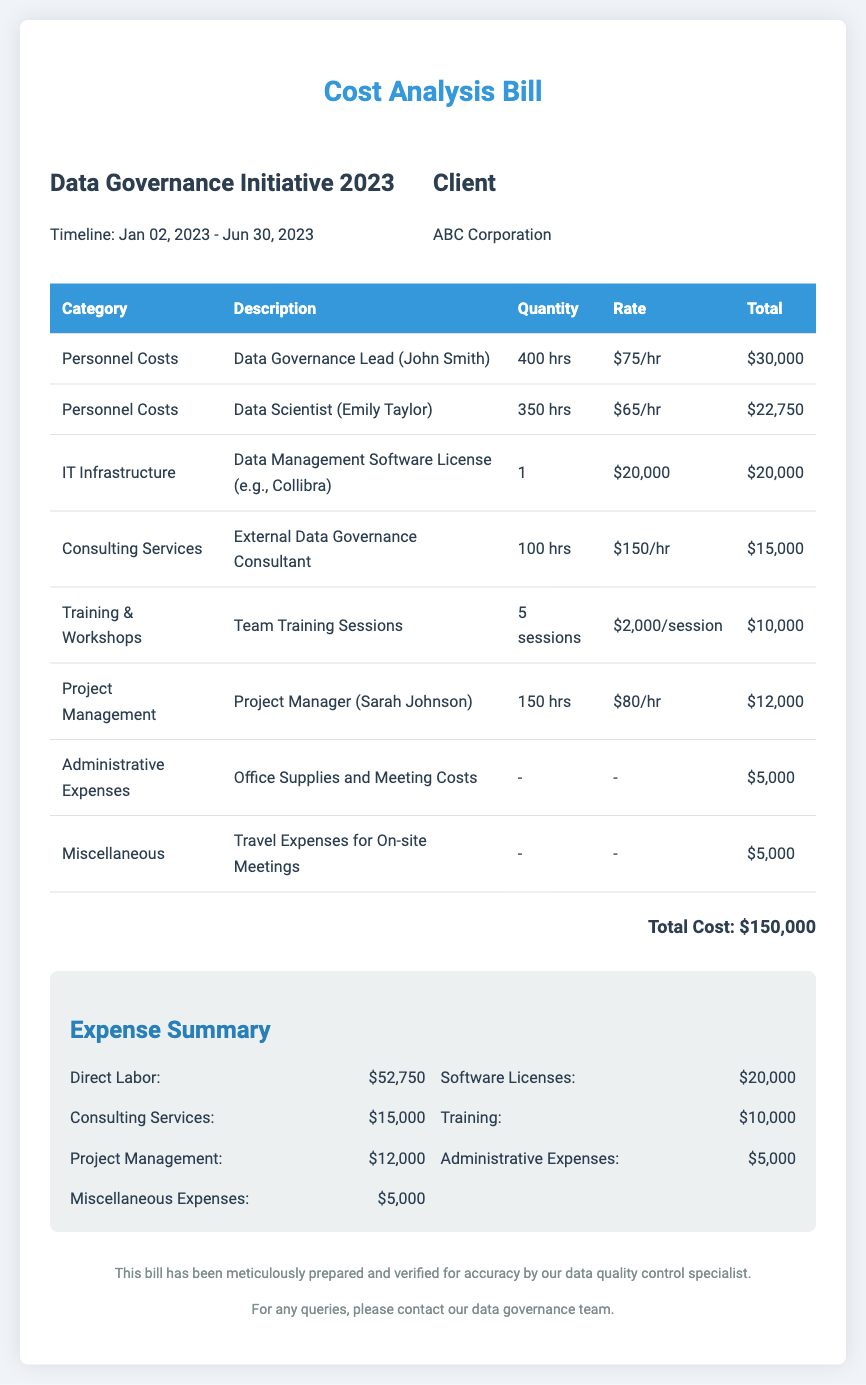What is the total cost? The total cost is explicitly stated at the end of the document, totaling $150,000.
Answer: $150,000 Who is the Data Governance Lead? The document provides the name of the Data Governance Lead as John Smith.
Answer: John Smith What is the rate per hour for the Data Scientist? The rate per hour for the Data Scientist, Emily Taylor, is listed as $65/hr.
Answer: $65/hr How many training sessions were conducted? The number of training sessions is specified in the document as 5 sessions.
Answer: 5 sessions What was the expense for Administrative Expenses? The document lists the expense for Administrative Expenses to be $5,000.
Answer: $5,000 What percentage of the total cost is attributed to Direct Labor? The total Direct Labor cost is $52,750, and the total cost is $150,000, giving us a percentage of 35.17%.
Answer: 35.17% Which category had the highest expense? The category with the highest expense listed in the document is Personnel Costs.
Answer: Personnel Costs What is the timeline for the Data Governance Initiative? The timeline for the Data Governance Initiative is indicated as January 02, 2023 to June 30, 2023.
Answer: January 02, 2023 - June 30, 2023 